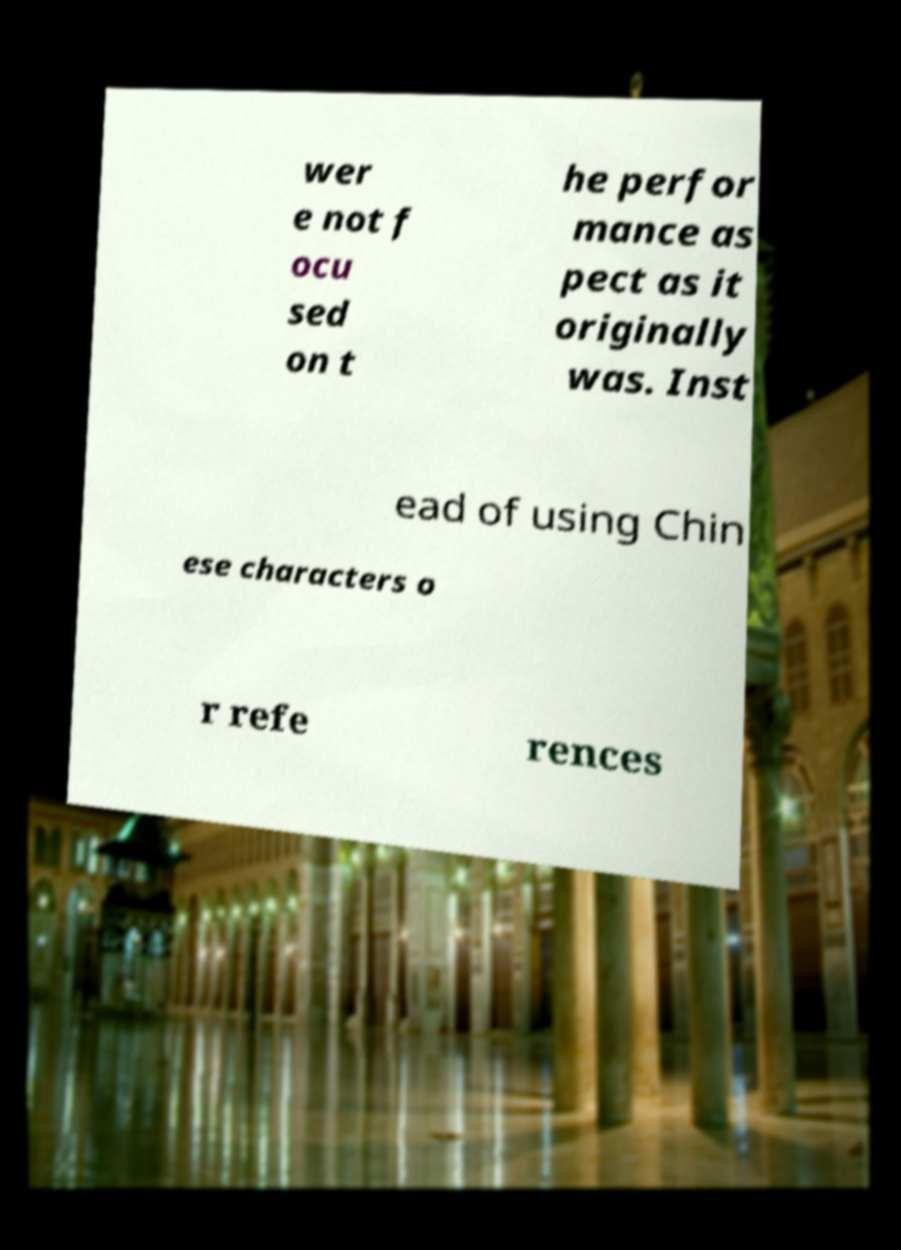Can you accurately transcribe the text from the provided image for me? wer e not f ocu sed on t he perfor mance as pect as it originally was. Inst ead of using Chin ese characters o r refe rences 